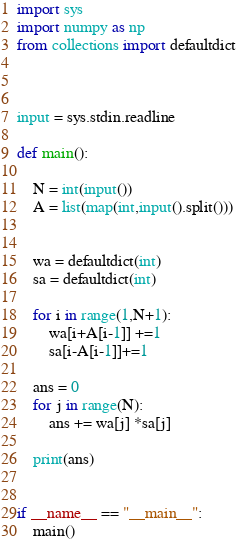<code> <loc_0><loc_0><loc_500><loc_500><_Python_>import sys
import numpy as np
from collections import defaultdict



input = sys.stdin.readline

def main():

    N = int(input())
    A = list(map(int,input().split()))


    wa = defaultdict(int)
    sa = defaultdict(int)

    for i in range(1,N+1):
        wa[i+A[i-1]] +=1
        sa[i-A[i-1]]+=1

    ans = 0
    for j in range(N):
        ans += wa[j] *sa[j]

    print(ans)


if __name__ == "__main__":
    main()</code> 